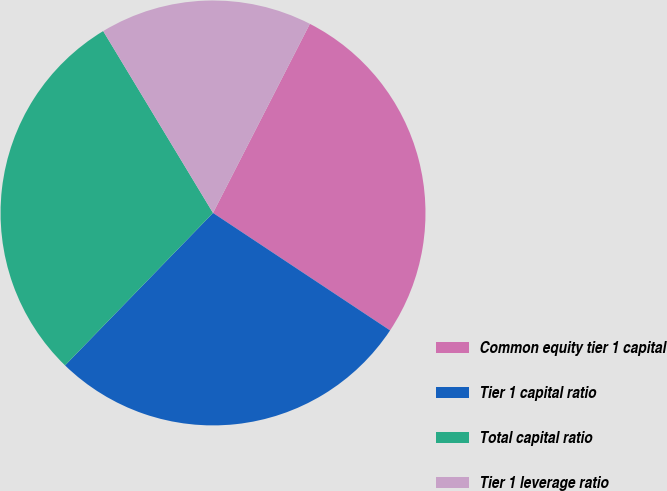<chart> <loc_0><loc_0><loc_500><loc_500><pie_chart><fcel>Common equity tier 1 capital<fcel>Tier 1 capital ratio<fcel>Total capital ratio<fcel>Tier 1 leverage ratio<nl><fcel>26.79%<fcel>27.94%<fcel>29.09%<fcel>16.18%<nl></chart> 